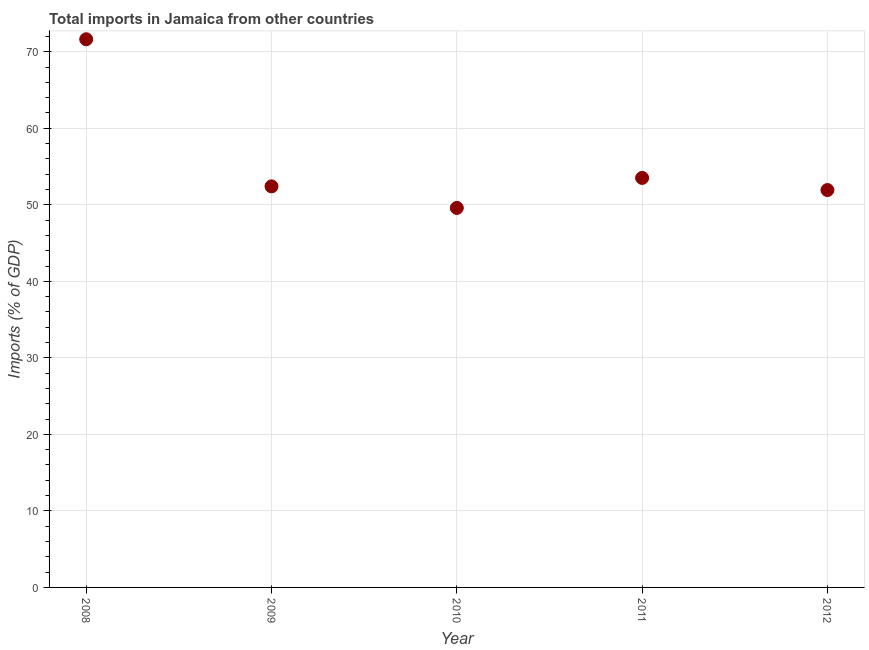What is the total imports in 2010?
Keep it short and to the point. 49.59. Across all years, what is the maximum total imports?
Offer a terse response. 71.63. Across all years, what is the minimum total imports?
Your answer should be very brief. 49.59. In which year was the total imports maximum?
Provide a short and direct response. 2008. What is the sum of the total imports?
Offer a terse response. 279.08. What is the difference between the total imports in 2009 and 2011?
Provide a short and direct response. -1.1. What is the average total imports per year?
Your answer should be compact. 55.82. What is the median total imports?
Provide a short and direct response. 52.41. What is the ratio of the total imports in 2008 to that in 2010?
Make the answer very short. 1.44. What is the difference between the highest and the second highest total imports?
Your answer should be compact. 18.12. What is the difference between the highest and the lowest total imports?
Your answer should be very brief. 22.04. Does the total imports monotonically increase over the years?
Keep it short and to the point. No. What is the difference between two consecutive major ticks on the Y-axis?
Your response must be concise. 10. Are the values on the major ticks of Y-axis written in scientific E-notation?
Offer a very short reply. No. Does the graph contain any zero values?
Make the answer very short. No. What is the title of the graph?
Offer a terse response. Total imports in Jamaica from other countries. What is the label or title of the Y-axis?
Keep it short and to the point. Imports (% of GDP). What is the Imports (% of GDP) in 2008?
Ensure brevity in your answer.  71.63. What is the Imports (% of GDP) in 2009?
Your response must be concise. 52.41. What is the Imports (% of GDP) in 2010?
Ensure brevity in your answer.  49.59. What is the Imports (% of GDP) in 2011?
Provide a succinct answer. 53.51. What is the Imports (% of GDP) in 2012?
Your response must be concise. 51.93. What is the difference between the Imports (% of GDP) in 2008 and 2009?
Your answer should be very brief. 19.22. What is the difference between the Imports (% of GDP) in 2008 and 2010?
Offer a terse response. 22.04. What is the difference between the Imports (% of GDP) in 2008 and 2011?
Provide a short and direct response. 18.12. What is the difference between the Imports (% of GDP) in 2008 and 2012?
Your answer should be compact. 19.71. What is the difference between the Imports (% of GDP) in 2009 and 2010?
Keep it short and to the point. 2.82. What is the difference between the Imports (% of GDP) in 2009 and 2011?
Keep it short and to the point. -1.1. What is the difference between the Imports (% of GDP) in 2009 and 2012?
Keep it short and to the point. 0.48. What is the difference between the Imports (% of GDP) in 2010 and 2011?
Ensure brevity in your answer.  -3.92. What is the difference between the Imports (% of GDP) in 2010 and 2012?
Ensure brevity in your answer.  -2.34. What is the difference between the Imports (% of GDP) in 2011 and 2012?
Provide a succinct answer. 1.59. What is the ratio of the Imports (% of GDP) in 2008 to that in 2009?
Your answer should be compact. 1.37. What is the ratio of the Imports (% of GDP) in 2008 to that in 2010?
Provide a short and direct response. 1.44. What is the ratio of the Imports (% of GDP) in 2008 to that in 2011?
Offer a very short reply. 1.34. What is the ratio of the Imports (% of GDP) in 2008 to that in 2012?
Your response must be concise. 1.38. What is the ratio of the Imports (% of GDP) in 2009 to that in 2010?
Your response must be concise. 1.06. What is the ratio of the Imports (% of GDP) in 2009 to that in 2011?
Ensure brevity in your answer.  0.98. What is the ratio of the Imports (% of GDP) in 2009 to that in 2012?
Provide a succinct answer. 1.01. What is the ratio of the Imports (% of GDP) in 2010 to that in 2011?
Keep it short and to the point. 0.93. What is the ratio of the Imports (% of GDP) in 2010 to that in 2012?
Make the answer very short. 0.95. What is the ratio of the Imports (% of GDP) in 2011 to that in 2012?
Offer a very short reply. 1.03. 